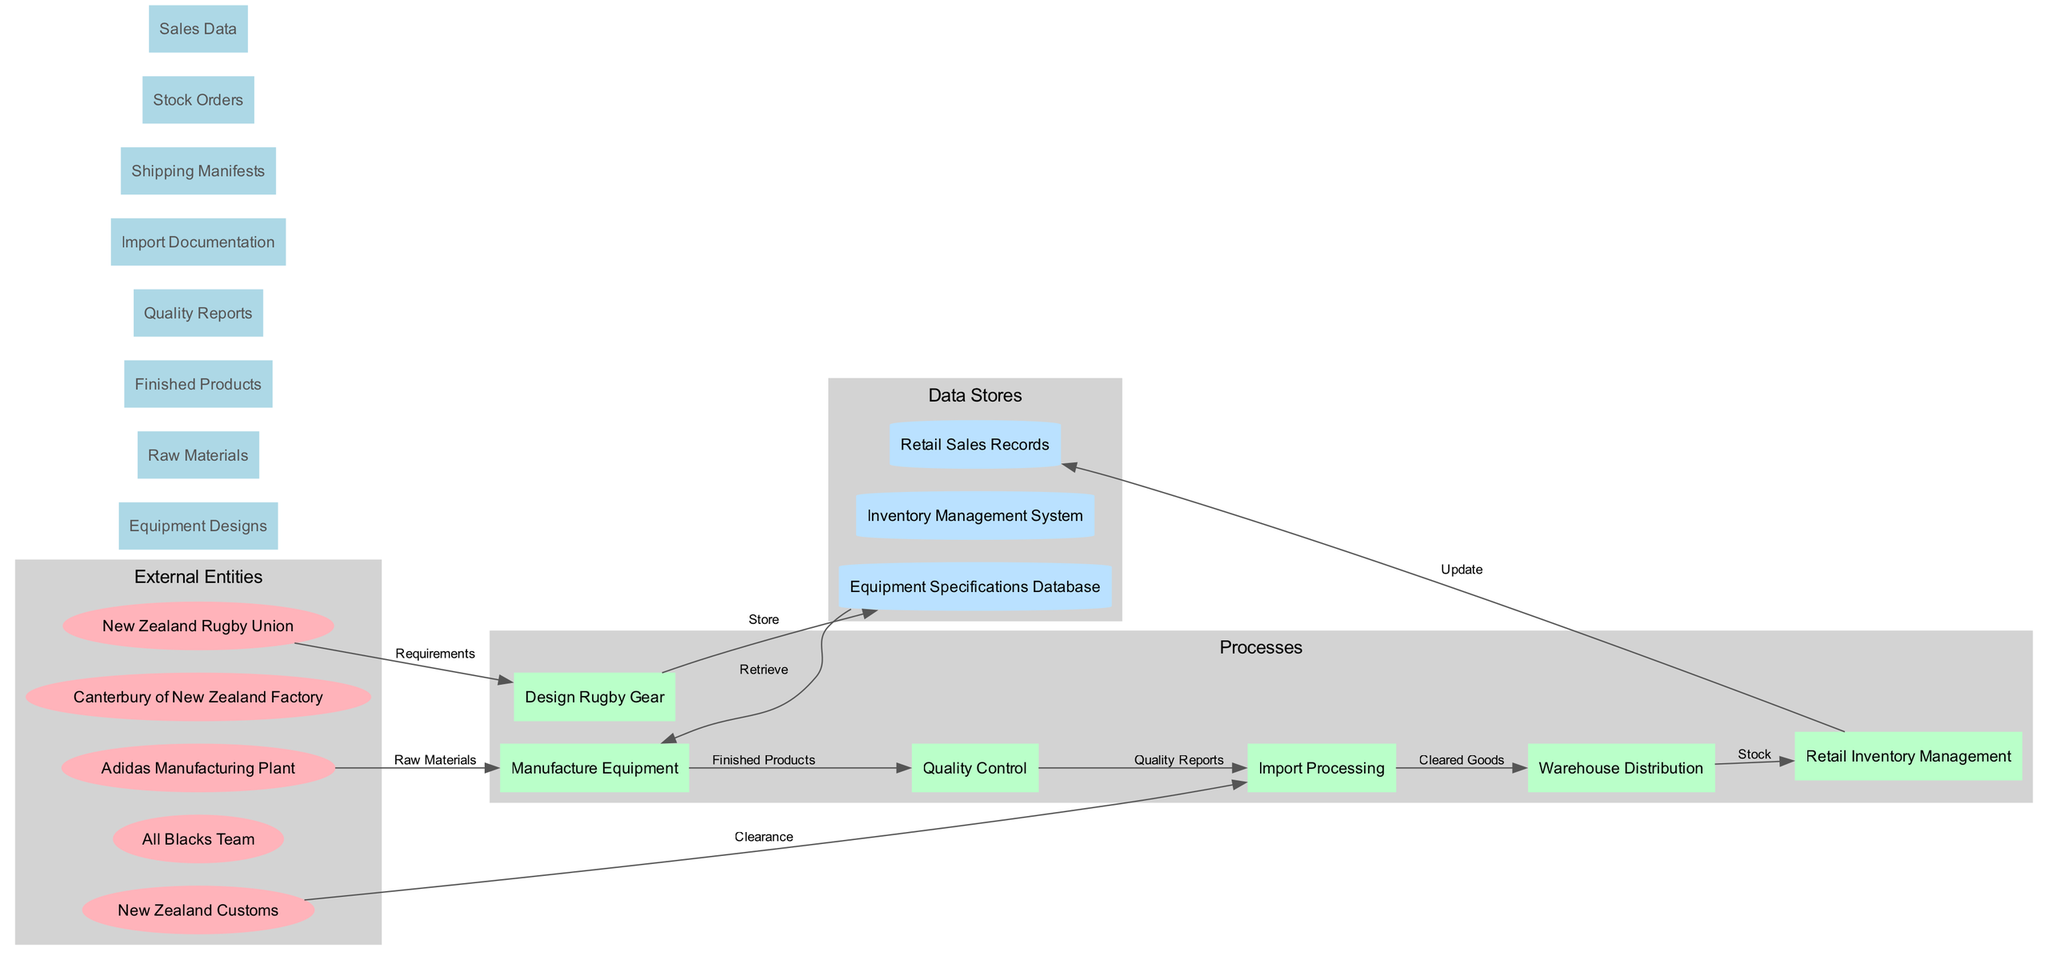What is the total number of external entities in the diagram? The diagram lists five external entities: New Zealand Rugby Union, All Blacks Team, Adidas Manufacturing Plant, Canterbury of New Zealand Factory, and New Zealand Customs. Counting these entities gives us a total of five.
Answer: 5 What data is stored in the Equipment Specifications Database? The Equipment Specifications Database stores the equipment designs submitted during the design process. This is indicated by the flow 'Equipment Designs' that connects to the database, showing that designs are entered for storage.
Answer: Equipment Designs Which process directly follows Quality Control? The flow from the Quality Control process leads to the Import Processing phase, indicating that after quality checks are completed, the goods are processed for importation. Therefore, the process directly following Quality Control is Import Processing.
Answer: Import Processing How many processes are depicted in the diagram? The diagram consists of six processes: Design Rugby Gear, Manufacture Equipment, Quality Control, Import Processing, Warehouse Distribution, and Retail Inventory Management. Counting these gives us six distinct processes.
Answer: 6 What is the purpose of the Shipping Manifests data flow? The Shipping Manifests data flow is part of the import processing sequence; it represents the documentation needed to confirm what goods are being shipped and is essential for clearance at customs. This flows into the Import Processing step.
Answer: Clearance Which entity provides raw materials for manufacturing equipment? The Adidas Manufacturing Plant is responsible for supplying the raw materials necessary for the manufacturing equipment process. The flow indicates this relationship directly from Adidas to Manufacture Equipment.
Answer: Adidas Manufacturing Plant What is updated by the Retail Inventory Management process? The Retail Sales Records are updated as a result of actions taken during the Retail Inventory Management process. This can be inferred from the flow that connects these two points where stock updates lead to sales records.
Answer: Retail Sales Records What type of data store is used to manage inventory? The Inventory Management System is the specific data store utilized to handle and keep track of inventory levels throughout the different processes, as indicated in the diagram.
Answer: Inventory Management System What connects the New Zealand Rugby Union to the Design Rugby Gear process? The requirement flow connects the New Zealand Rugby Union to the Design Rugby Gear process, indicating that the entity provides the necessary requirements for the design of rugby gear.
Answer: Requirements 